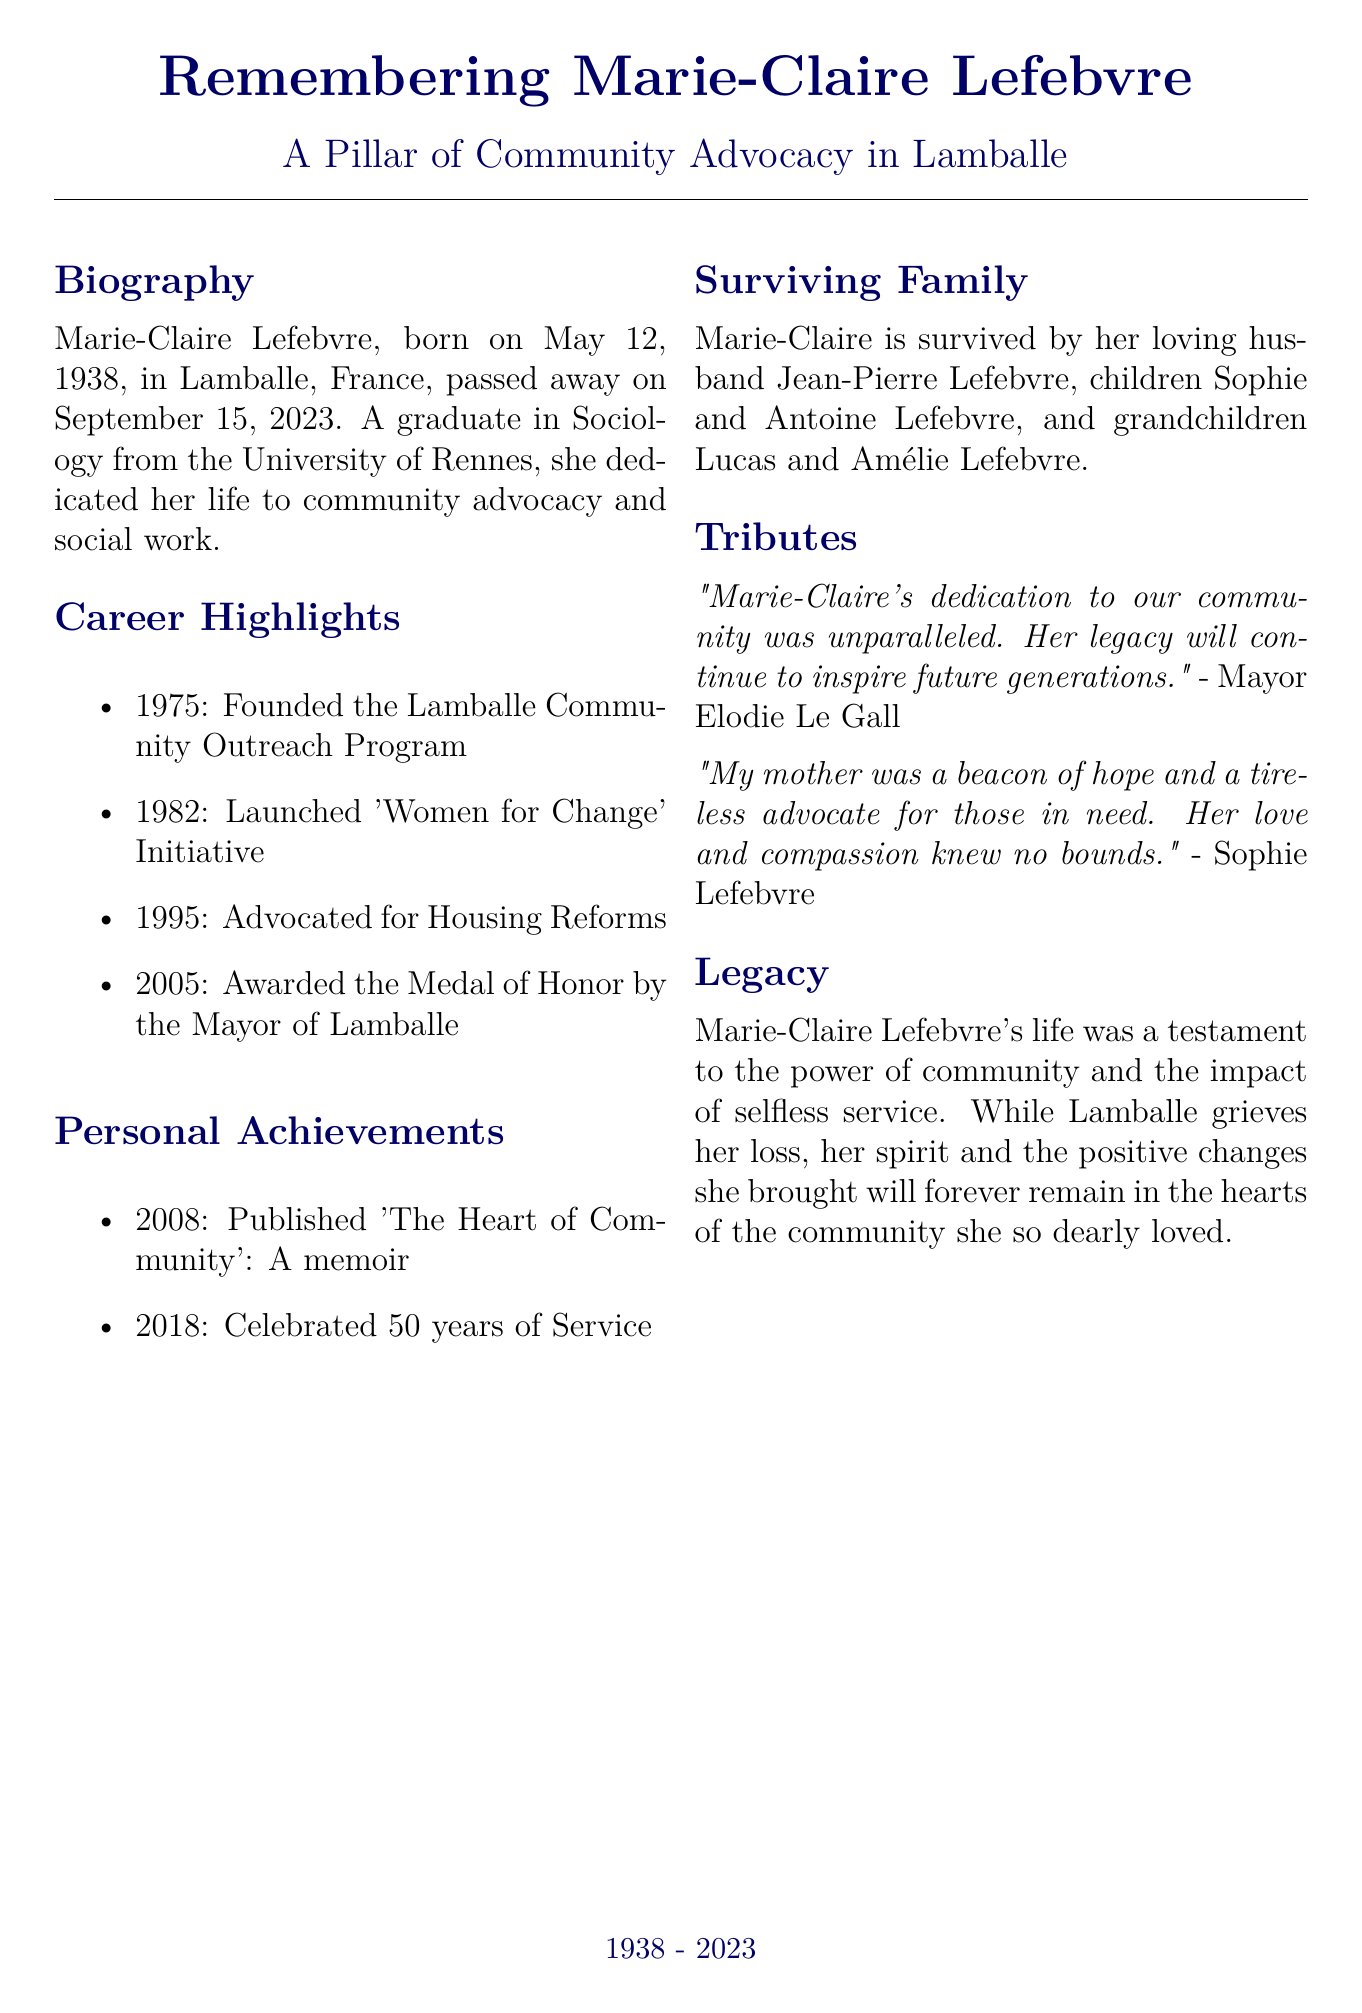What is Marie-Claire Lefebvre's birth date? The document states that Marie-Claire Lefebvre was born on May 12, 1938.
Answer: May 12, 1938 What did Marie-Claire Lefebvre graduate in? It mentions that she graduated in Sociology from the University of Rennes.
Answer: Sociology What year was the Lamballe Community Outreach Program founded? The document indicates that the program was founded in 1975.
Answer: 1975 Who was awarded the Medal of Honor in 2005? It states that Marie-Claire Lefebvre was awarded the Medal of Honor by the Mayor of Lamballe in 2005.
Answer: Marie-Claire Lefebvre How many years did Marie-Claire Lefebvre serve before her 50 years celebration? The document notes that she celebrated 50 years of service in 2018, meaning she started her service in 1968.
Answer: 50 years What is the relationship of Sophie Lefebvre to Marie-Claire? The document clarifies that Sophie Lefebvre is one of Marie-Claire's children.
Answer: Daughter What theme is emphasized in the legacy section of the document? The legacy section highlights the power of community and the impact of selfless service as central themes.
Answer: Community and service What was the title of Marie-Claire Lefebvre's published memoir? It states that she published a memoir titled "The Heart of Community."
Answer: The Heart of Community Who expressed a tribute stating, "Her legacy will continue to inspire future generations"? The document attributes this quote to Mayor Elodie Le Gall.
Answer: Mayor Elodie Le Gall 